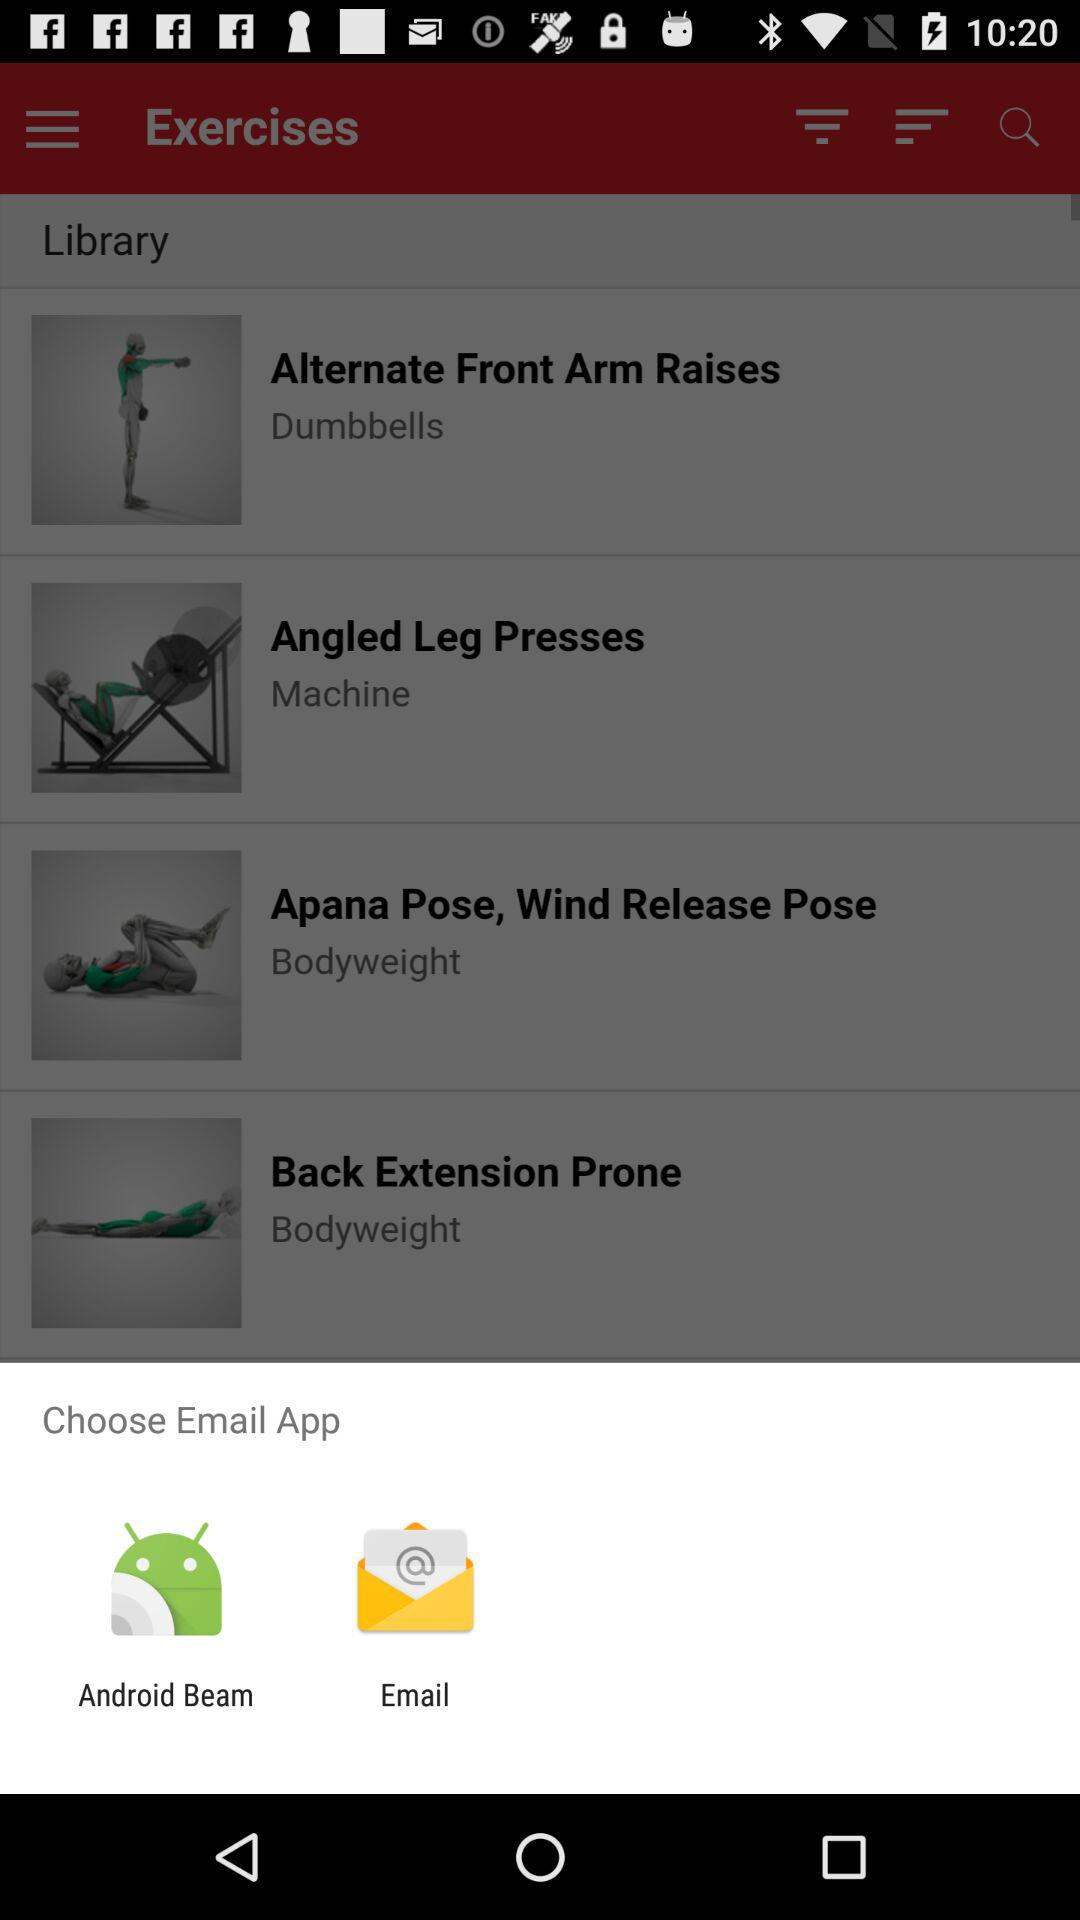Which exercise uses dumbbells? The exercise that uses dumbbells is "Alternate Front Arm Raises". 